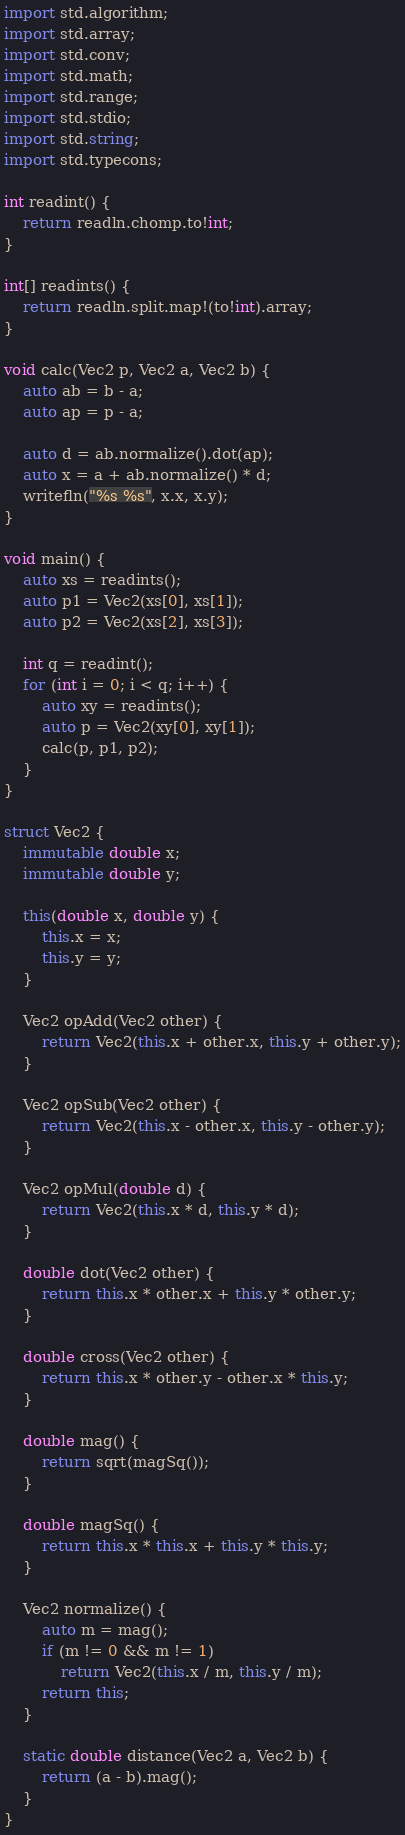<code> <loc_0><loc_0><loc_500><loc_500><_D_>import std.algorithm;
import std.array;
import std.conv;
import std.math;
import std.range;
import std.stdio;
import std.string;
import std.typecons;

int readint() {
    return readln.chomp.to!int;
}

int[] readints() {
    return readln.split.map!(to!int).array;
}

void calc(Vec2 p, Vec2 a, Vec2 b) {
    auto ab = b - a;
    auto ap = p - a;

    auto d = ab.normalize().dot(ap);
    auto x = a + ab.normalize() * d;
    writefln("%s %s", x.x, x.y);
}

void main() {
    auto xs = readints();
    auto p1 = Vec2(xs[0], xs[1]);
    auto p2 = Vec2(xs[2], xs[3]);

    int q = readint();
    for (int i = 0; i < q; i++) {
        auto xy = readints();
        auto p = Vec2(xy[0], xy[1]);
        calc(p, p1, p2);
    }
}

struct Vec2 {
    immutable double x;
    immutable double y;

    this(double x, double y) {
        this.x = x;
        this.y = y;
    }

    Vec2 opAdd(Vec2 other) {
        return Vec2(this.x + other.x, this.y + other.y);
    }

    Vec2 opSub(Vec2 other) {
        return Vec2(this.x - other.x, this.y - other.y);
    }

    Vec2 opMul(double d) {
        return Vec2(this.x * d, this.y * d);
    }

    double dot(Vec2 other) {
        return this.x * other.x + this.y * other.y;
    }

    double cross(Vec2 other) {
        return this.x * other.y - other.x * this.y;
    }

    double mag() {
        return sqrt(magSq());
    }

    double magSq() {
        return this.x * this.x + this.y * this.y;
    }

    Vec2 normalize() {
        auto m = mag();
        if (m != 0 && m != 1)
            return Vec2(this.x / m, this.y / m);
        return this;
    }

    static double distance(Vec2 a, Vec2 b) {
        return (a - b).mag();
    }
}</code> 